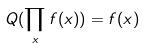<formula> <loc_0><loc_0><loc_500><loc_500>Q ( \prod _ { x } f ( x ) ) = f ( x )</formula> 